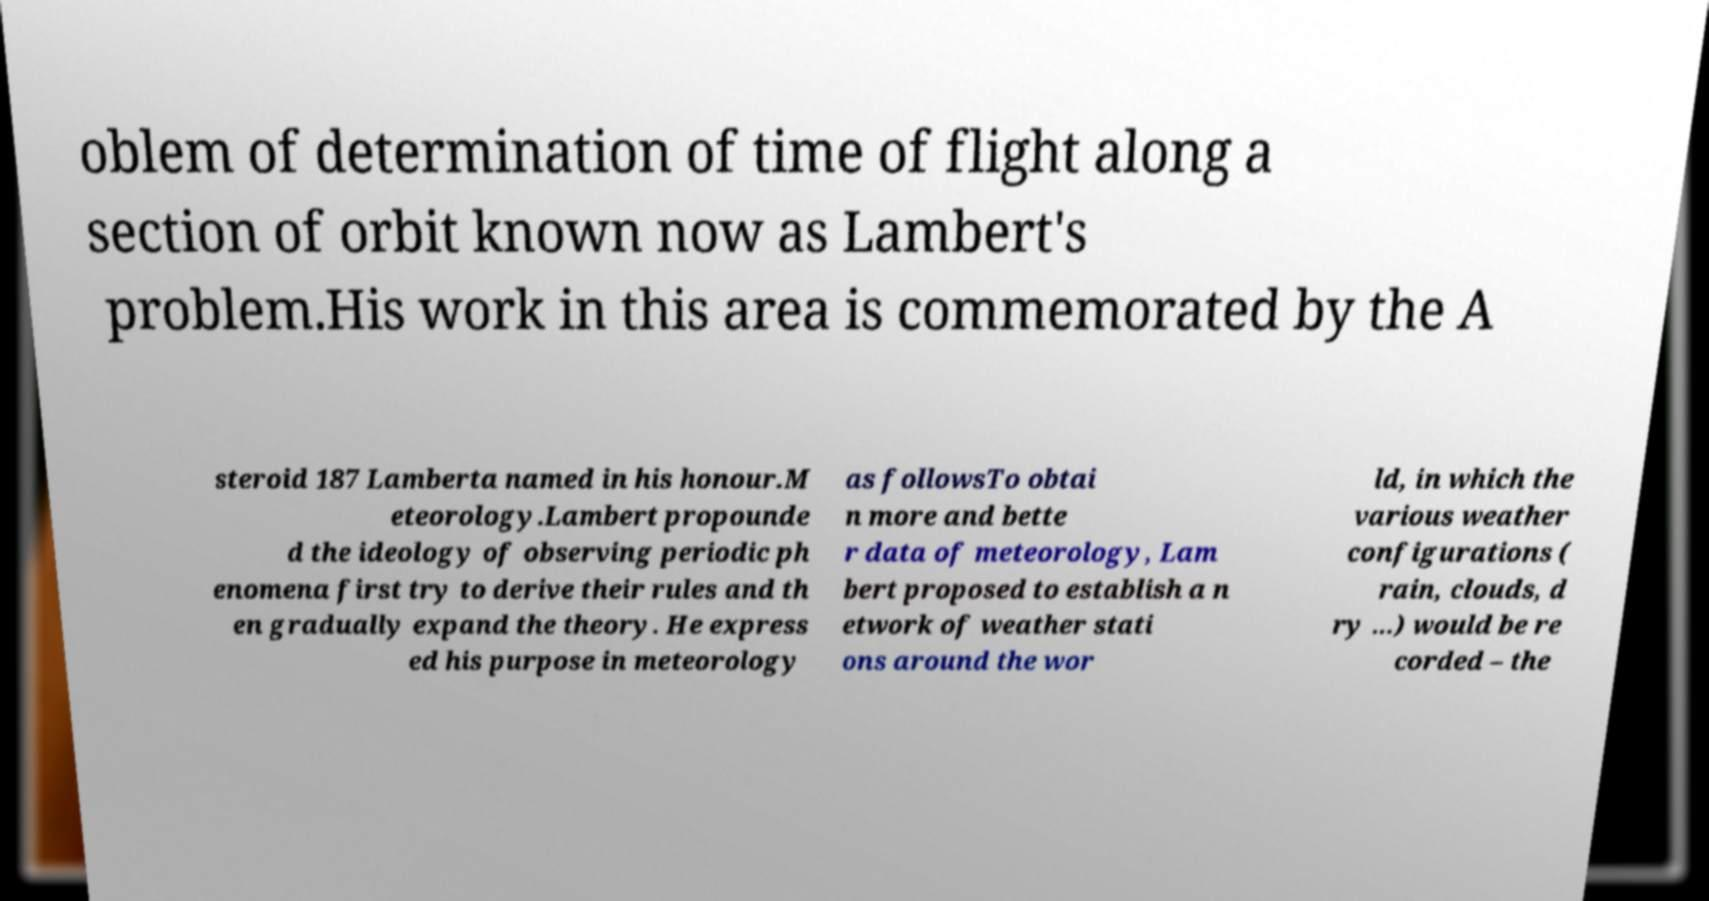Please identify and transcribe the text found in this image. oblem of determination of time of flight along a section of orbit known now as Lambert's problem.His work in this area is commemorated by the A steroid 187 Lamberta named in his honour.M eteorology.Lambert propounde d the ideology of observing periodic ph enomena first try to derive their rules and th en gradually expand the theory. He express ed his purpose in meteorology as followsTo obtai n more and bette r data of meteorology, Lam bert proposed to establish a n etwork of weather stati ons around the wor ld, in which the various weather configurations ( rain, clouds, d ry ...) would be re corded – the 